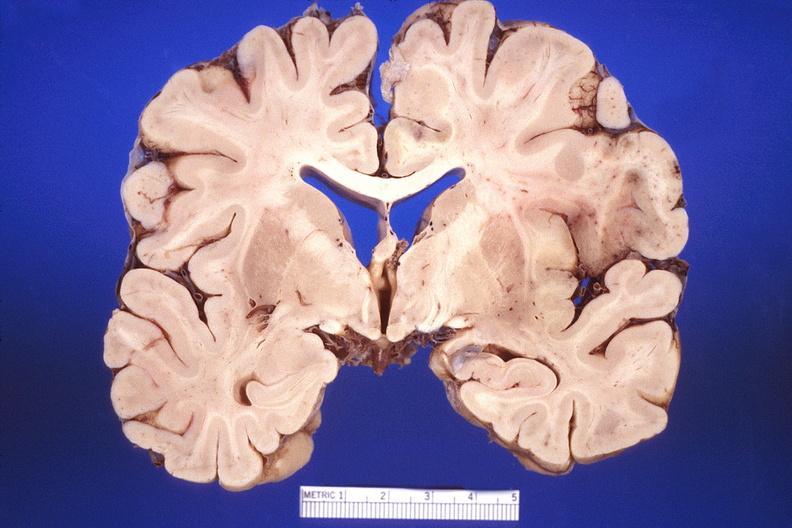what does this image show?
Answer the question using a single word or phrase. Brain 